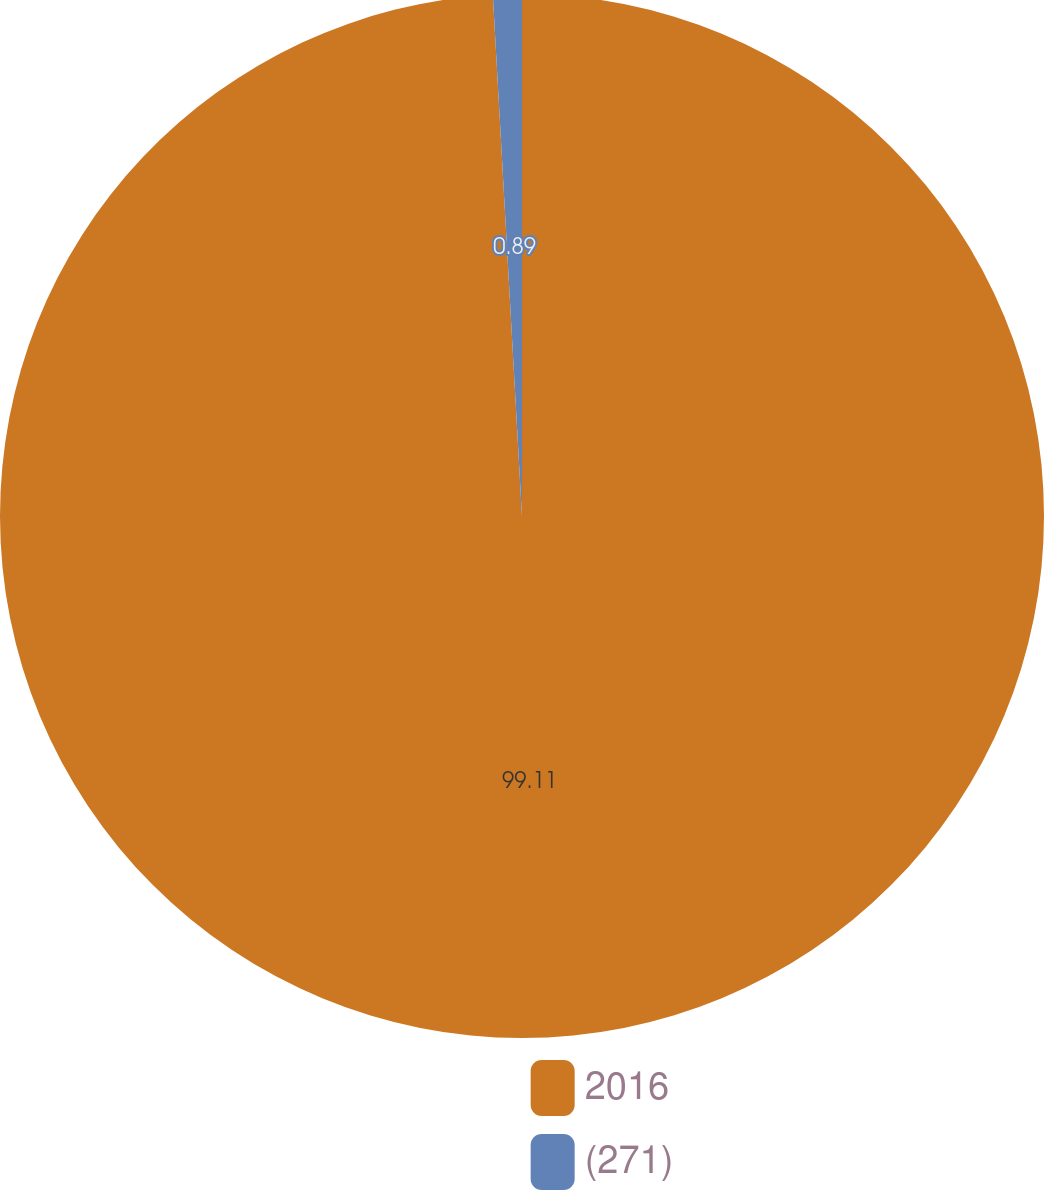Convert chart to OTSL. <chart><loc_0><loc_0><loc_500><loc_500><pie_chart><fcel>2016<fcel>(271)<nl><fcel>99.11%<fcel>0.89%<nl></chart> 